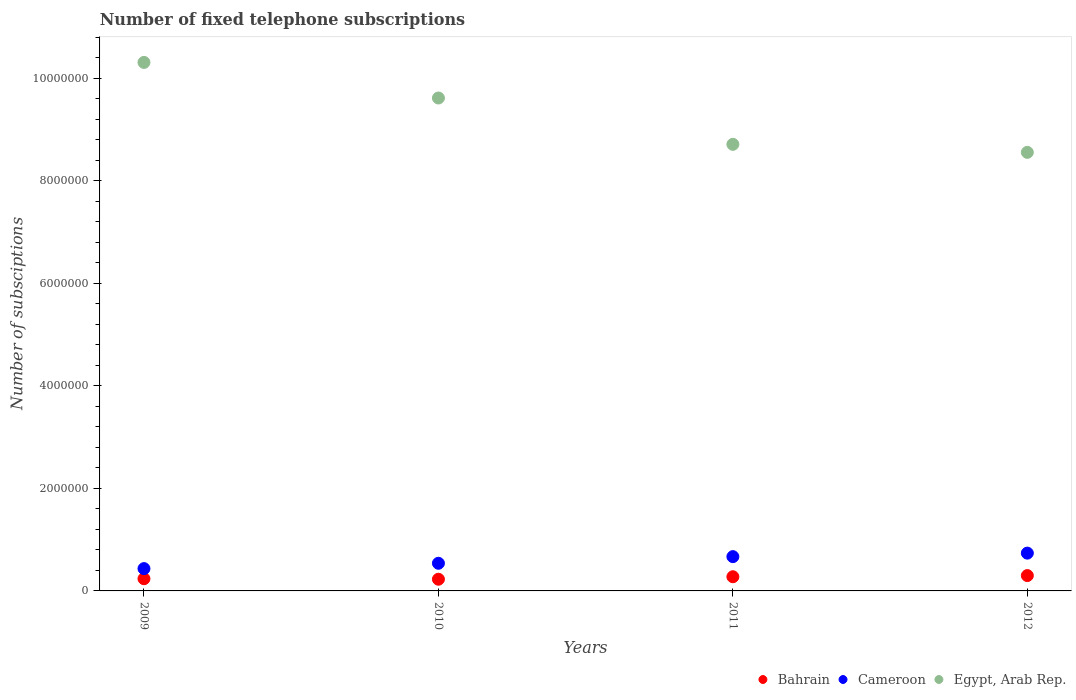Is the number of dotlines equal to the number of legend labels?
Make the answer very short. Yes. What is the number of fixed telephone subscriptions in Bahrain in 2009?
Provide a short and direct response. 2.38e+05. Across all years, what is the maximum number of fixed telephone subscriptions in Bahrain?
Offer a terse response. 2.99e+05. Across all years, what is the minimum number of fixed telephone subscriptions in Bahrain?
Your answer should be compact. 2.28e+05. What is the total number of fixed telephone subscriptions in Bahrain in the graph?
Your answer should be very brief. 1.04e+06. What is the difference between the number of fixed telephone subscriptions in Cameroon in 2009 and that in 2010?
Provide a succinct answer. -1.04e+05. What is the difference between the number of fixed telephone subscriptions in Egypt, Arab Rep. in 2012 and the number of fixed telephone subscriptions in Bahrain in 2010?
Offer a terse response. 8.33e+06. What is the average number of fixed telephone subscriptions in Bahrain per year?
Ensure brevity in your answer.  2.60e+05. In the year 2009, what is the difference between the number of fixed telephone subscriptions in Bahrain and number of fixed telephone subscriptions in Cameroon?
Your answer should be compact. -1.97e+05. What is the ratio of the number of fixed telephone subscriptions in Bahrain in 2009 to that in 2012?
Offer a terse response. 0.79. Is the difference between the number of fixed telephone subscriptions in Bahrain in 2009 and 2012 greater than the difference between the number of fixed telephone subscriptions in Cameroon in 2009 and 2012?
Provide a short and direct response. Yes. What is the difference between the highest and the second highest number of fixed telephone subscriptions in Egypt, Arab Rep.?
Make the answer very short. 6.94e+05. What is the difference between the highest and the lowest number of fixed telephone subscriptions in Cameroon?
Offer a terse response. 3.02e+05. In how many years, is the number of fixed telephone subscriptions in Egypt, Arab Rep. greater than the average number of fixed telephone subscriptions in Egypt, Arab Rep. taken over all years?
Give a very brief answer. 2. Is the sum of the number of fixed telephone subscriptions in Egypt, Arab Rep. in 2009 and 2012 greater than the maximum number of fixed telephone subscriptions in Bahrain across all years?
Ensure brevity in your answer.  Yes. Is the number of fixed telephone subscriptions in Egypt, Arab Rep. strictly greater than the number of fixed telephone subscriptions in Bahrain over the years?
Offer a terse response. Yes. How many dotlines are there?
Offer a very short reply. 3. What is the difference between two consecutive major ticks on the Y-axis?
Provide a short and direct response. 2.00e+06. What is the title of the graph?
Your answer should be compact. Number of fixed telephone subscriptions. Does "Brazil" appear as one of the legend labels in the graph?
Offer a very short reply. No. What is the label or title of the Y-axis?
Offer a very short reply. Number of subsciptions. What is the Number of subsciptions of Bahrain in 2009?
Provide a short and direct response. 2.38e+05. What is the Number of subsciptions of Cameroon in 2009?
Make the answer very short. 4.35e+05. What is the Number of subsciptions of Egypt, Arab Rep. in 2009?
Your answer should be very brief. 1.03e+07. What is the Number of subsciptions in Bahrain in 2010?
Your response must be concise. 2.28e+05. What is the Number of subsciptions of Cameroon in 2010?
Offer a terse response. 5.40e+05. What is the Number of subsciptions in Egypt, Arab Rep. in 2010?
Provide a short and direct response. 9.62e+06. What is the Number of subsciptions in Bahrain in 2011?
Offer a very short reply. 2.77e+05. What is the Number of subsciptions in Cameroon in 2011?
Give a very brief answer. 6.69e+05. What is the Number of subsciptions in Egypt, Arab Rep. in 2011?
Your answer should be compact. 8.71e+06. What is the Number of subsciptions in Bahrain in 2012?
Ensure brevity in your answer.  2.99e+05. What is the Number of subsciptions of Cameroon in 2012?
Offer a terse response. 7.37e+05. What is the Number of subsciptions of Egypt, Arab Rep. in 2012?
Your response must be concise. 8.56e+06. Across all years, what is the maximum Number of subsciptions of Bahrain?
Offer a terse response. 2.99e+05. Across all years, what is the maximum Number of subsciptions in Cameroon?
Offer a very short reply. 7.37e+05. Across all years, what is the maximum Number of subsciptions in Egypt, Arab Rep.?
Make the answer very short. 1.03e+07. Across all years, what is the minimum Number of subsciptions of Bahrain?
Keep it short and to the point. 2.28e+05. Across all years, what is the minimum Number of subsciptions of Cameroon?
Provide a succinct answer. 4.35e+05. Across all years, what is the minimum Number of subsciptions in Egypt, Arab Rep.?
Your answer should be very brief. 8.56e+06. What is the total Number of subsciptions in Bahrain in the graph?
Offer a terse response. 1.04e+06. What is the total Number of subsciptions in Cameroon in the graph?
Your answer should be compact. 2.38e+06. What is the total Number of subsciptions of Egypt, Arab Rep. in the graph?
Your answer should be very brief. 3.72e+07. What is the difference between the Number of subsciptions of Bahrain in 2009 and that in 2010?
Offer a very short reply. 10000. What is the difference between the Number of subsciptions in Cameroon in 2009 and that in 2010?
Keep it short and to the point. -1.04e+05. What is the difference between the Number of subsciptions of Egypt, Arab Rep. in 2009 and that in 2010?
Your response must be concise. 6.94e+05. What is the difference between the Number of subsciptions in Bahrain in 2009 and that in 2011?
Offer a terse response. -3.85e+04. What is the difference between the Number of subsciptions in Cameroon in 2009 and that in 2011?
Make the answer very short. -2.34e+05. What is the difference between the Number of subsciptions of Egypt, Arab Rep. in 2009 and that in 2011?
Provide a short and direct response. 1.60e+06. What is the difference between the Number of subsciptions of Bahrain in 2009 and that in 2012?
Make the answer very short. -6.14e+04. What is the difference between the Number of subsciptions of Cameroon in 2009 and that in 2012?
Ensure brevity in your answer.  -3.02e+05. What is the difference between the Number of subsciptions of Egypt, Arab Rep. in 2009 and that in 2012?
Ensure brevity in your answer.  1.76e+06. What is the difference between the Number of subsciptions of Bahrain in 2010 and that in 2011?
Ensure brevity in your answer.  -4.85e+04. What is the difference between the Number of subsciptions of Cameroon in 2010 and that in 2011?
Your response must be concise. -1.29e+05. What is the difference between the Number of subsciptions in Egypt, Arab Rep. in 2010 and that in 2011?
Your response must be concise. 9.04e+05. What is the difference between the Number of subsciptions in Bahrain in 2010 and that in 2012?
Offer a terse response. -7.14e+04. What is the difference between the Number of subsciptions of Cameroon in 2010 and that in 2012?
Provide a succinct answer. -1.98e+05. What is the difference between the Number of subsciptions in Egypt, Arab Rep. in 2010 and that in 2012?
Give a very brief answer. 1.06e+06. What is the difference between the Number of subsciptions of Bahrain in 2011 and that in 2012?
Provide a short and direct response. -2.29e+04. What is the difference between the Number of subsciptions in Cameroon in 2011 and that in 2012?
Offer a terse response. -6.85e+04. What is the difference between the Number of subsciptions in Egypt, Arab Rep. in 2011 and that in 2012?
Provide a succinct answer. 1.57e+05. What is the difference between the Number of subsciptions of Bahrain in 2009 and the Number of subsciptions of Cameroon in 2010?
Keep it short and to the point. -3.02e+05. What is the difference between the Number of subsciptions of Bahrain in 2009 and the Number of subsciptions of Egypt, Arab Rep. in 2010?
Keep it short and to the point. -9.38e+06. What is the difference between the Number of subsciptions in Cameroon in 2009 and the Number of subsciptions in Egypt, Arab Rep. in 2010?
Provide a succinct answer. -9.18e+06. What is the difference between the Number of subsciptions of Bahrain in 2009 and the Number of subsciptions of Cameroon in 2011?
Give a very brief answer. -4.31e+05. What is the difference between the Number of subsciptions in Bahrain in 2009 and the Number of subsciptions in Egypt, Arab Rep. in 2011?
Your answer should be compact. -8.48e+06. What is the difference between the Number of subsciptions in Cameroon in 2009 and the Number of subsciptions in Egypt, Arab Rep. in 2011?
Offer a very short reply. -8.28e+06. What is the difference between the Number of subsciptions of Bahrain in 2009 and the Number of subsciptions of Cameroon in 2012?
Make the answer very short. -4.99e+05. What is the difference between the Number of subsciptions of Bahrain in 2009 and the Number of subsciptions of Egypt, Arab Rep. in 2012?
Give a very brief answer. -8.32e+06. What is the difference between the Number of subsciptions in Cameroon in 2009 and the Number of subsciptions in Egypt, Arab Rep. in 2012?
Your response must be concise. -8.12e+06. What is the difference between the Number of subsciptions in Bahrain in 2010 and the Number of subsciptions in Cameroon in 2011?
Your answer should be very brief. -4.41e+05. What is the difference between the Number of subsciptions of Bahrain in 2010 and the Number of subsciptions of Egypt, Arab Rep. in 2011?
Your answer should be very brief. -8.49e+06. What is the difference between the Number of subsciptions in Cameroon in 2010 and the Number of subsciptions in Egypt, Arab Rep. in 2011?
Your answer should be compact. -8.17e+06. What is the difference between the Number of subsciptions in Bahrain in 2010 and the Number of subsciptions in Cameroon in 2012?
Give a very brief answer. -5.09e+05. What is the difference between the Number of subsciptions in Bahrain in 2010 and the Number of subsciptions in Egypt, Arab Rep. in 2012?
Ensure brevity in your answer.  -8.33e+06. What is the difference between the Number of subsciptions of Cameroon in 2010 and the Number of subsciptions of Egypt, Arab Rep. in 2012?
Make the answer very short. -8.02e+06. What is the difference between the Number of subsciptions in Bahrain in 2011 and the Number of subsciptions in Cameroon in 2012?
Your response must be concise. -4.61e+05. What is the difference between the Number of subsciptions in Bahrain in 2011 and the Number of subsciptions in Egypt, Arab Rep. in 2012?
Keep it short and to the point. -8.28e+06. What is the difference between the Number of subsciptions of Cameroon in 2011 and the Number of subsciptions of Egypt, Arab Rep. in 2012?
Your answer should be very brief. -7.89e+06. What is the average Number of subsciptions of Bahrain per year?
Your response must be concise. 2.60e+05. What is the average Number of subsciptions of Cameroon per year?
Offer a terse response. 5.95e+05. What is the average Number of subsciptions of Egypt, Arab Rep. per year?
Your response must be concise. 9.30e+06. In the year 2009, what is the difference between the Number of subsciptions of Bahrain and Number of subsciptions of Cameroon?
Your answer should be compact. -1.97e+05. In the year 2009, what is the difference between the Number of subsciptions of Bahrain and Number of subsciptions of Egypt, Arab Rep.?
Your response must be concise. -1.01e+07. In the year 2009, what is the difference between the Number of subsciptions in Cameroon and Number of subsciptions in Egypt, Arab Rep.?
Your response must be concise. -9.88e+06. In the year 2010, what is the difference between the Number of subsciptions of Bahrain and Number of subsciptions of Cameroon?
Give a very brief answer. -3.12e+05. In the year 2010, what is the difference between the Number of subsciptions in Bahrain and Number of subsciptions in Egypt, Arab Rep.?
Keep it short and to the point. -9.39e+06. In the year 2010, what is the difference between the Number of subsciptions of Cameroon and Number of subsciptions of Egypt, Arab Rep.?
Ensure brevity in your answer.  -9.08e+06. In the year 2011, what is the difference between the Number of subsciptions in Bahrain and Number of subsciptions in Cameroon?
Provide a succinct answer. -3.92e+05. In the year 2011, what is the difference between the Number of subsciptions in Bahrain and Number of subsciptions in Egypt, Arab Rep.?
Provide a succinct answer. -8.44e+06. In the year 2011, what is the difference between the Number of subsciptions of Cameroon and Number of subsciptions of Egypt, Arab Rep.?
Offer a terse response. -8.05e+06. In the year 2012, what is the difference between the Number of subsciptions of Bahrain and Number of subsciptions of Cameroon?
Offer a terse response. -4.38e+05. In the year 2012, what is the difference between the Number of subsciptions in Bahrain and Number of subsciptions in Egypt, Arab Rep.?
Provide a succinct answer. -8.26e+06. In the year 2012, what is the difference between the Number of subsciptions of Cameroon and Number of subsciptions of Egypt, Arab Rep.?
Your answer should be very brief. -7.82e+06. What is the ratio of the Number of subsciptions in Bahrain in 2009 to that in 2010?
Offer a terse response. 1.04. What is the ratio of the Number of subsciptions in Cameroon in 2009 to that in 2010?
Keep it short and to the point. 0.81. What is the ratio of the Number of subsciptions in Egypt, Arab Rep. in 2009 to that in 2010?
Offer a terse response. 1.07. What is the ratio of the Number of subsciptions in Bahrain in 2009 to that in 2011?
Make the answer very short. 0.86. What is the ratio of the Number of subsciptions in Cameroon in 2009 to that in 2011?
Keep it short and to the point. 0.65. What is the ratio of the Number of subsciptions in Egypt, Arab Rep. in 2009 to that in 2011?
Make the answer very short. 1.18. What is the ratio of the Number of subsciptions in Bahrain in 2009 to that in 2012?
Your answer should be compact. 0.79. What is the ratio of the Number of subsciptions of Cameroon in 2009 to that in 2012?
Ensure brevity in your answer.  0.59. What is the ratio of the Number of subsciptions of Egypt, Arab Rep. in 2009 to that in 2012?
Give a very brief answer. 1.21. What is the ratio of the Number of subsciptions in Bahrain in 2010 to that in 2011?
Your answer should be very brief. 0.82. What is the ratio of the Number of subsciptions in Cameroon in 2010 to that in 2011?
Keep it short and to the point. 0.81. What is the ratio of the Number of subsciptions in Egypt, Arab Rep. in 2010 to that in 2011?
Give a very brief answer. 1.1. What is the ratio of the Number of subsciptions of Bahrain in 2010 to that in 2012?
Provide a succinct answer. 0.76. What is the ratio of the Number of subsciptions of Cameroon in 2010 to that in 2012?
Provide a short and direct response. 0.73. What is the ratio of the Number of subsciptions in Egypt, Arab Rep. in 2010 to that in 2012?
Your answer should be compact. 1.12. What is the ratio of the Number of subsciptions of Bahrain in 2011 to that in 2012?
Your answer should be compact. 0.92. What is the ratio of the Number of subsciptions of Cameroon in 2011 to that in 2012?
Make the answer very short. 0.91. What is the ratio of the Number of subsciptions of Egypt, Arab Rep. in 2011 to that in 2012?
Your answer should be very brief. 1.02. What is the difference between the highest and the second highest Number of subsciptions of Bahrain?
Make the answer very short. 2.29e+04. What is the difference between the highest and the second highest Number of subsciptions of Cameroon?
Make the answer very short. 6.85e+04. What is the difference between the highest and the second highest Number of subsciptions in Egypt, Arab Rep.?
Provide a short and direct response. 6.94e+05. What is the difference between the highest and the lowest Number of subsciptions in Bahrain?
Your answer should be compact. 7.14e+04. What is the difference between the highest and the lowest Number of subsciptions of Cameroon?
Offer a terse response. 3.02e+05. What is the difference between the highest and the lowest Number of subsciptions in Egypt, Arab Rep.?
Offer a very short reply. 1.76e+06. 